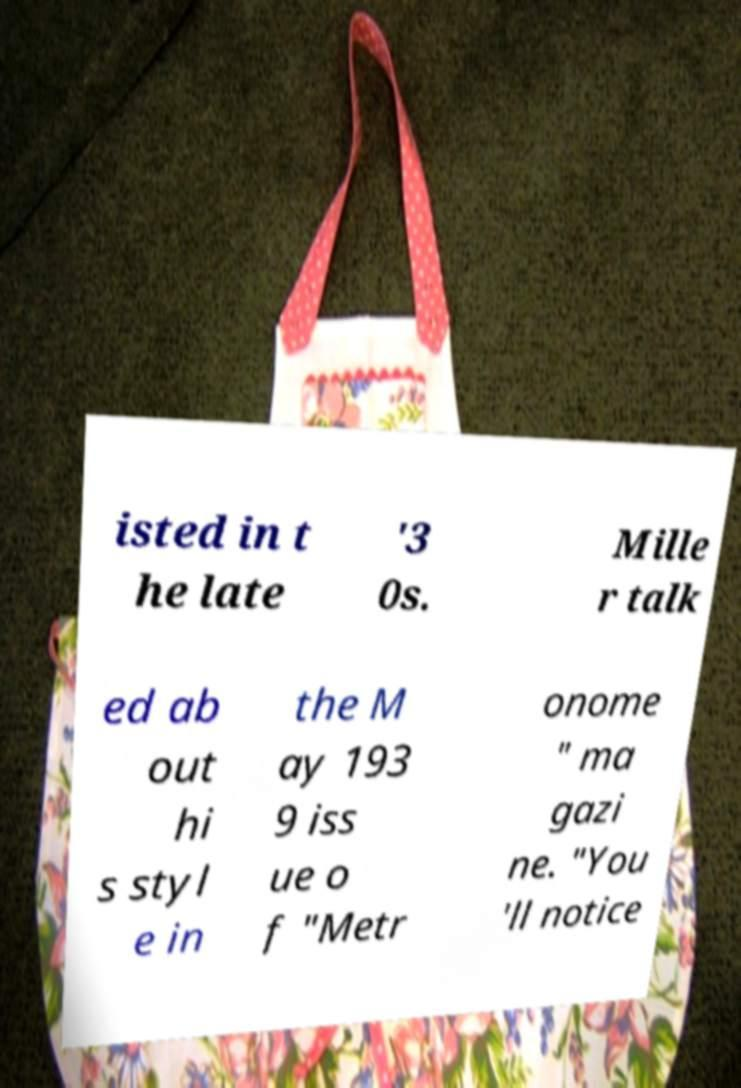I need the written content from this picture converted into text. Can you do that? isted in t he late '3 0s. Mille r talk ed ab out hi s styl e in the M ay 193 9 iss ue o f "Metr onome " ma gazi ne. "You 'll notice 